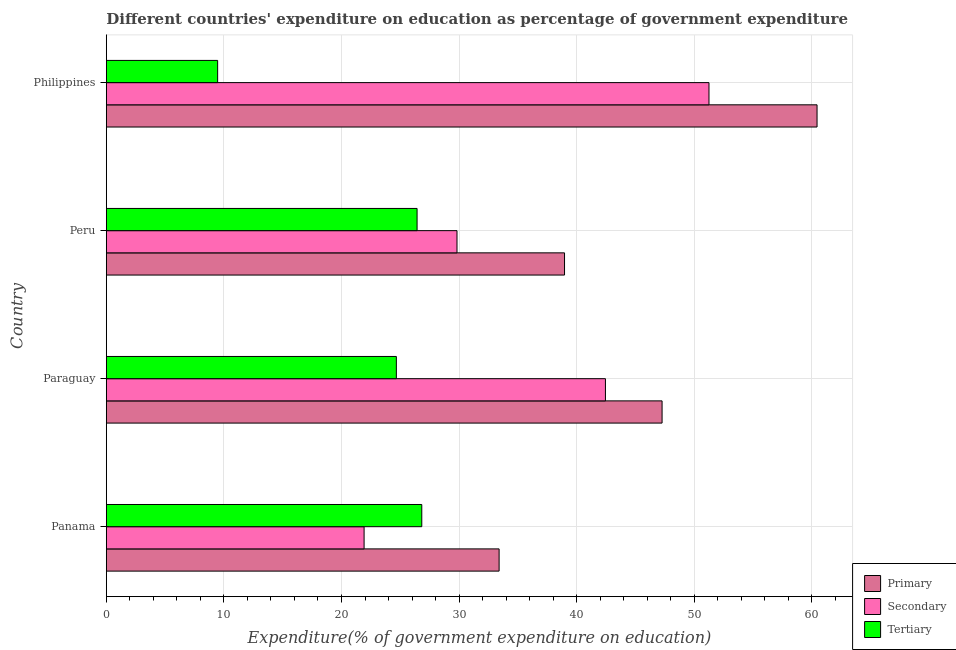How many different coloured bars are there?
Offer a terse response. 3. How many groups of bars are there?
Your response must be concise. 4. Are the number of bars per tick equal to the number of legend labels?
Offer a terse response. Yes. How many bars are there on the 1st tick from the bottom?
Your response must be concise. 3. What is the expenditure on tertiary education in Paraguay?
Provide a succinct answer. 24.67. Across all countries, what is the maximum expenditure on primary education?
Offer a terse response. 60.45. Across all countries, what is the minimum expenditure on secondary education?
Provide a succinct answer. 21.92. In which country was the expenditure on secondary education minimum?
Provide a succinct answer. Panama. What is the total expenditure on tertiary education in the graph?
Provide a succinct answer. 87.39. What is the difference between the expenditure on tertiary education in Paraguay and that in Peru?
Provide a short and direct response. -1.76. What is the difference between the expenditure on primary education in Paraguay and the expenditure on secondary education in Peru?
Offer a terse response. 17.44. What is the average expenditure on secondary education per country?
Give a very brief answer. 36.36. What is the difference between the expenditure on tertiary education and expenditure on primary education in Paraguay?
Offer a very short reply. -22.6. What is the ratio of the expenditure on primary education in Paraguay to that in Philippines?
Offer a very short reply. 0.78. What is the difference between the highest and the second highest expenditure on primary education?
Make the answer very short. 13.18. What is the difference between the highest and the lowest expenditure on primary education?
Give a very brief answer. 27.04. Is the sum of the expenditure on tertiary education in Paraguay and Philippines greater than the maximum expenditure on primary education across all countries?
Your response must be concise. No. What does the 1st bar from the top in Panama represents?
Ensure brevity in your answer.  Tertiary. What does the 2nd bar from the bottom in Paraguay represents?
Your response must be concise. Secondary. How many bars are there?
Keep it short and to the point. 12. Are all the bars in the graph horizontal?
Give a very brief answer. Yes. How many countries are there in the graph?
Make the answer very short. 4. What is the difference between two consecutive major ticks on the X-axis?
Keep it short and to the point. 10. Are the values on the major ticks of X-axis written in scientific E-notation?
Keep it short and to the point. No. Does the graph contain any zero values?
Ensure brevity in your answer.  No. What is the title of the graph?
Your answer should be compact. Different countries' expenditure on education as percentage of government expenditure. Does "Oil sources" appear as one of the legend labels in the graph?
Your response must be concise. No. What is the label or title of the X-axis?
Your answer should be compact. Expenditure(% of government expenditure on education). What is the Expenditure(% of government expenditure on education) in Primary in Panama?
Your answer should be very brief. 33.41. What is the Expenditure(% of government expenditure on education) in Secondary in Panama?
Give a very brief answer. 21.92. What is the Expenditure(% of government expenditure on education) in Tertiary in Panama?
Ensure brevity in your answer.  26.83. What is the Expenditure(% of government expenditure on education) of Primary in Paraguay?
Offer a terse response. 47.27. What is the Expenditure(% of government expenditure on education) in Secondary in Paraguay?
Your answer should be compact. 42.45. What is the Expenditure(% of government expenditure on education) in Tertiary in Paraguay?
Provide a short and direct response. 24.67. What is the Expenditure(% of government expenditure on education) in Primary in Peru?
Your answer should be very brief. 38.97. What is the Expenditure(% of government expenditure on education) in Secondary in Peru?
Ensure brevity in your answer.  29.82. What is the Expenditure(% of government expenditure on education) in Tertiary in Peru?
Make the answer very short. 26.43. What is the Expenditure(% of government expenditure on education) of Primary in Philippines?
Your answer should be very brief. 60.45. What is the Expenditure(% of government expenditure on education) of Secondary in Philippines?
Provide a short and direct response. 51.26. What is the Expenditure(% of government expenditure on education) of Tertiary in Philippines?
Your answer should be compact. 9.47. Across all countries, what is the maximum Expenditure(% of government expenditure on education) in Primary?
Provide a short and direct response. 60.45. Across all countries, what is the maximum Expenditure(% of government expenditure on education) of Secondary?
Offer a very short reply. 51.26. Across all countries, what is the maximum Expenditure(% of government expenditure on education) of Tertiary?
Provide a succinct answer. 26.83. Across all countries, what is the minimum Expenditure(% of government expenditure on education) in Primary?
Offer a very short reply. 33.41. Across all countries, what is the minimum Expenditure(% of government expenditure on education) of Secondary?
Keep it short and to the point. 21.92. Across all countries, what is the minimum Expenditure(% of government expenditure on education) in Tertiary?
Keep it short and to the point. 9.47. What is the total Expenditure(% of government expenditure on education) in Primary in the graph?
Make the answer very short. 180.09. What is the total Expenditure(% of government expenditure on education) in Secondary in the graph?
Offer a very short reply. 145.45. What is the total Expenditure(% of government expenditure on education) in Tertiary in the graph?
Ensure brevity in your answer.  87.39. What is the difference between the Expenditure(% of government expenditure on education) of Primary in Panama and that in Paraguay?
Your answer should be compact. -13.86. What is the difference between the Expenditure(% of government expenditure on education) of Secondary in Panama and that in Paraguay?
Your answer should be compact. -20.53. What is the difference between the Expenditure(% of government expenditure on education) in Tertiary in Panama and that in Paraguay?
Provide a succinct answer. 2.16. What is the difference between the Expenditure(% of government expenditure on education) of Primary in Panama and that in Peru?
Provide a short and direct response. -5.56. What is the difference between the Expenditure(% of government expenditure on education) of Secondary in Panama and that in Peru?
Provide a succinct answer. -7.9. What is the difference between the Expenditure(% of government expenditure on education) in Tertiary in Panama and that in Peru?
Give a very brief answer. 0.4. What is the difference between the Expenditure(% of government expenditure on education) in Primary in Panama and that in Philippines?
Keep it short and to the point. -27.04. What is the difference between the Expenditure(% of government expenditure on education) in Secondary in Panama and that in Philippines?
Offer a terse response. -29.33. What is the difference between the Expenditure(% of government expenditure on education) of Tertiary in Panama and that in Philippines?
Offer a very short reply. 17.36. What is the difference between the Expenditure(% of government expenditure on education) of Primary in Paraguay and that in Peru?
Your answer should be compact. 8.3. What is the difference between the Expenditure(% of government expenditure on education) in Secondary in Paraguay and that in Peru?
Provide a short and direct response. 12.62. What is the difference between the Expenditure(% of government expenditure on education) of Tertiary in Paraguay and that in Peru?
Offer a very short reply. -1.76. What is the difference between the Expenditure(% of government expenditure on education) in Primary in Paraguay and that in Philippines?
Provide a short and direct response. -13.18. What is the difference between the Expenditure(% of government expenditure on education) of Secondary in Paraguay and that in Philippines?
Ensure brevity in your answer.  -8.81. What is the difference between the Expenditure(% of government expenditure on education) of Tertiary in Paraguay and that in Philippines?
Ensure brevity in your answer.  15.2. What is the difference between the Expenditure(% of government expenditure on education) in Primary in Peru and that in Philippines?
Offer a very short reply. -21.48. What is the difference between the Expenditure(% of government expenditure on education) in Secondary in Peru and that in Philippines?
Offer a very short reply. -21.43. What is the difference between the Expenditure(% of government expenditure on education) in Tertiary in Peru and that in Philippines?
Your answer should be very brief. 16.96. What is the difference between the Expenditure(% of government expenditure on education) in Primary in Panama and the Expenditure(% of government expenditure on education) in Secondary in Paraguay?
Provide a succinct answer. -9.04. What is the difference between the Expenditure(% of government expenditure on education) in Primary in Panama and the Expenditure(% of government expenditure on education) in Tertiary in Paraguay?
Offer a very short reply. 8.74. What is the difference between the Expenditure(% of government expenditure on education) of Secondary in Panama and the Expenditure(% of government expenditure on education) of Tertiary in Paraguay?
Offer a terse response. -2.75. What is the difference between the Expenditure(% of government expenditure on education) in Primary in Panama and the Expenditure(% of government expenditure on education) in Secondary in Peru?
Ensure brevity in your answer.  3.58. What is the difference between the Expenditure(% of government expenditure on education) in Primary in Panama and the Expenditure(% of government expenditure on education) in Tertiary in Peru?
Give a very brief answer. 6.98. What is the difference between the Expenditure(% of government expenditure on education) of Secondary in Panama and the Expenditure(% of government expenditure on education) of Tertiary in Peru?
Ensure brevity in your answer.  -4.51. What is the difference between the Expenditure(% of government expenditure on education) of Primary in Panama and the Expenditure(% of government expenditure on education) of Secondary in Philippines?
Ensure brevity in your answer.  -17.85. What is the difference between the Expenditure(% of government expenditure on education) in Primary in Panama and the Expenditure(% of government expenditure on education) in Tertiary in Philippines?
Provide a short and direct response. 23.94. What is the difference between the Expenditure(% of government expenditure on education) in Secondary in Panama and the Expenditure(% of government expenditure on education) in Tertiary in Philippines?
Give a very brief answer. 12.45. What is the difference between the Expenditure(% of government expenditure on education) of Primary in Paraguay and the Expenditure(% of government expenditure on education) of Secondary in Peru?
Offer a terse response. 17.44. What is the difference between the Expenditure(% of government expenditure on education) of Primary in Paraguay and the Expenditure(% of government expenditure on education) of Tertiary in Peru?
Offer a terse response. 20.84. What is the difference between the Expenditure(% of government expenditure on education) in Secondary in Paraguay and the Expenditure(% of government expenditure on education) in Tertiary in Peru?
Provide a short and direct response. 16.02. What is the difference between the Expenditure(% of government expenditure on education) of Primary in Paraguay and the Expenditure(% of government expenditure on education) of Secondary in Philippines?
Your response must be concise. -3.99. What is the difference between the Expenditure(% of government expenditure on education) of Primary in Paraguay and the Expenditure(% of government expenditure on education) of Tertiary in Philippines?
Your answer should be very brief. 37.8. What is the difference between the Expenditure(% of government expenditure on education) of Secondary in Paraguay and the Expenditure(% of government expenditure on education) of Tertiary in Philippines?
Make the answer very short. 32.98. What is the difference between the Expenditure(% of government expenditure on education) in Primary in Peru and the Expenditure(% of government expenditure on education) in Secondary in Philippines?
Provide a short and direct response. -12.29. What is the difference between the Expenditure(% of government expenditure on education) of Primary in Peru and the Expenditure(% of government expenditure on education) of Tertiary in Philippines?
Offer a terse response. 29.5. What is the difference between the Expenditure(% of government expenditure on education) in Secondary in Peru and the Expenditure(% of government expenditure on education) in Tertiary in Philippines?
Give a very brief answer. 20.36. What is the average Expenditure(% of government expenditure on education) in Primary per country?
Your response must be concise. 45.02. What is the average Expenditure(% of government expenditure on education) of Secondary per country?
Provide a short and direct response. 36.36. What is the average Expenditure(% of government expenditure on education) of Tertiary per country?
Provide a succinct answer. 21.85. What is the difference between the Expenditure(% of government expenditure on education) of Primary and Expenditure(% of government expenditure on education) of Secondary in Panama?
Give a very brief answer. 11.48. What is the difference between the Expenditure(% of government expenditure on education) of Primary and Expenditure(% of government expenditure on education) of Tertiary in Panama?
Keep it short and to the point. 6.58. What is the difference between the Expenditure(% of government expenditure on education) of Secondary and Expenditure(% of government expenditure on education) of Tertiary in Panama?
Your answer should be very brief. -4.91. What is the difference between the Expenditure(% of government expenditure on education) in Primary and Expenditure(% of government expenditure on education) in Secondary in Paraguay?
Give a very brief answer. 4.82. What is the difference between the Expenditure(% of government expenditure on education) in Primary and Expenditure(% of government expenditure on education) in Tertiary in Paraguay?
Make the answer very short. 22.6. What is the difference between the Expenditure(% of government expenditure on education) in Secondary and Expenditure(% of government expenditure on education) in Tertiary in Paraguay?
Your response must be concise. 17.78. What is the difference between the Expenditure(% of government expenditure on education) of Primary and Expenditure(% of government expenditure on education) of Secondary in Peru?
Your answer should be very brief. 9.14. What is the difference between the Expenditure(% of government expenditure on education) of Primary and Expenditure(% of government expenditure on education) of Tertiary in Peru?
Ensure brevity in your answer.  12.54. What is the difference between the Expenditure(% of government expenditure on education) in Secondary and Expenditure(% of government expenditure on education) in Tertiary in Peru?
Make the answer very short. 3.4. What is the difference between the Expenditure(% of government expenditure on education) of Primary and Expenditure(% of government expenditure on education) of Secondary in Philippines?
Make the answer very short. 9.19. What is the difference between the Expenditure(% of government expenditure on education) of Primary and Expenditure(% of government expenditure on education) of Tertiary in Philippines?
Keep it short and to the point. 50.98. What is the difference between the Expenditure(% of government expenditure on education) of Secondary and Expenditure(% of government expenditure on education) of Tertiary in Philippines?
Give a very brief answer. 41.79. What is the ratio of the Expenditure(% of government expenditure on education) in Primary in Panama to that in Paraguay?
Ensure brevity in your answer.  0.71. What is the ratio of the Expenditure(% of government expenditure on education) of Secondary in Panama to that in Paraguay?
Your response must be concise. 0.52. What is the ratio of the Expenditure(% of government expenditure on education) in Tertiary in Panama to that in Paraguay?
Your answer should be compact. 1.09. What is the ratio of the Expenditure(% of government expenditure on education) of Primary in Panama to that in Peru?
Offer a very short reply. 0.86. What is the ratio of the Expenditure(% of government expenditure on education) in Secondary in Panama to that in Peru?
Keep it short and to the point. 0.73. What is the ratio of the Expenditure(% of government expenditure on education) of Tertiary in Panama to that in Peru?
Keep it short and to the point. 1.02. What is the ratio of the Expenditure(% of government expenditure on education) in Primary in Panama to that in Philippines?
Your response must be concise. 0.55. What is the ratio of the Expenditure(% of government expenditure on education) in Secondary in Panama to that in Philippines?
Provide a short and direct response. 0.43. What is the ratio of the Expenditure(% of government expenditure on education) of Tertiary in Panama to that in Philippines?
Give a very brief answer. 2.83. What is the ratio of the Expenditure(% of government expenditure on education) in Primary in Paraguay to that in Peru?
Make the answer very short. 1.21. What is the ratio of the Expenditure(% of government expenditure on education) in Secondary in Paraguay to that in Peru?
Make the answer very short. 1.42. What is the ratio of the Expenditure(% of government expenditure on education) of Tertiary in Paraguay to that in Peru?
Provide a short and direct response. 0.93. What is the ratio of the Expenditure(% of government expenditure on education) in Primary in Paraguay to that in Philippines?
Offer a very short reply. 0.78. What is the ratio of the Expenditure(% of government expenditure on education) of Secondary in Paraguay to that in Philippines?
Make the answer very short. 0.83. What is the ratio of the Expenditure(% of government expenditure on education) of Tertiary in Paraguay to that in Philippines?
Offer a terse response. 2.61. What is the ratio of the Expenditure(% of government expenditure on education) in Primary in Peru to that in Philippines?
Provide a short and direct response. 0.64. What is the ratio of the Expenditure(% of government expenditure on education) in Secondary in Peru to that in Philippines?
Your answer should be very brief. 0.58. What is the ratio of the Expenditure(% of government expenditure on education) of Tertiary in Peru to that in Philippines?
Offer a terse response. 2.79. What is the difference between the highest and the second highest Expenditure(% of government expenditure on education) of Primary?
Make the answer very short. 13.18. What is the difference between the highest and the second highest Expenditure(% of government expenditure on education) of Secondary?
Provide a short and direct response. 8.81. What is the difference between the highest and the second highest Expenditure(% of government expenditure on education) of Tertiary?
Ensure brevity in your answer.  0.4. What is the difference between the highest and the lowest Expenditure(% of government expenditure on education) of Primary?
Your response must be concise. 27.04. What is the difference between the highest and the lowest Expenditure(% of government expenditure on education) in Secondary?
Give a very brief answer. 29.33. What is the difference between the highest and the lowest Expenditure(% of government expenditure on education) of Tertiary?
Your answer should be very brief. 17.36. 